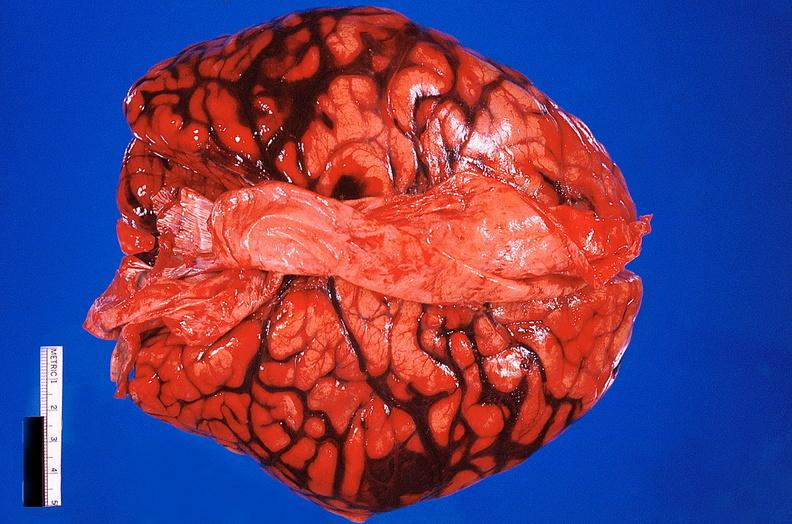why does this image show brain, subarachanoid hemorrhage?
Answer the question using a single word or phrase. Due to ruptured aneurysm 